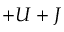Convert formula to latex. <formula><loc_0><loc_0><loc_500><loc_500>+ U + J</formula> 